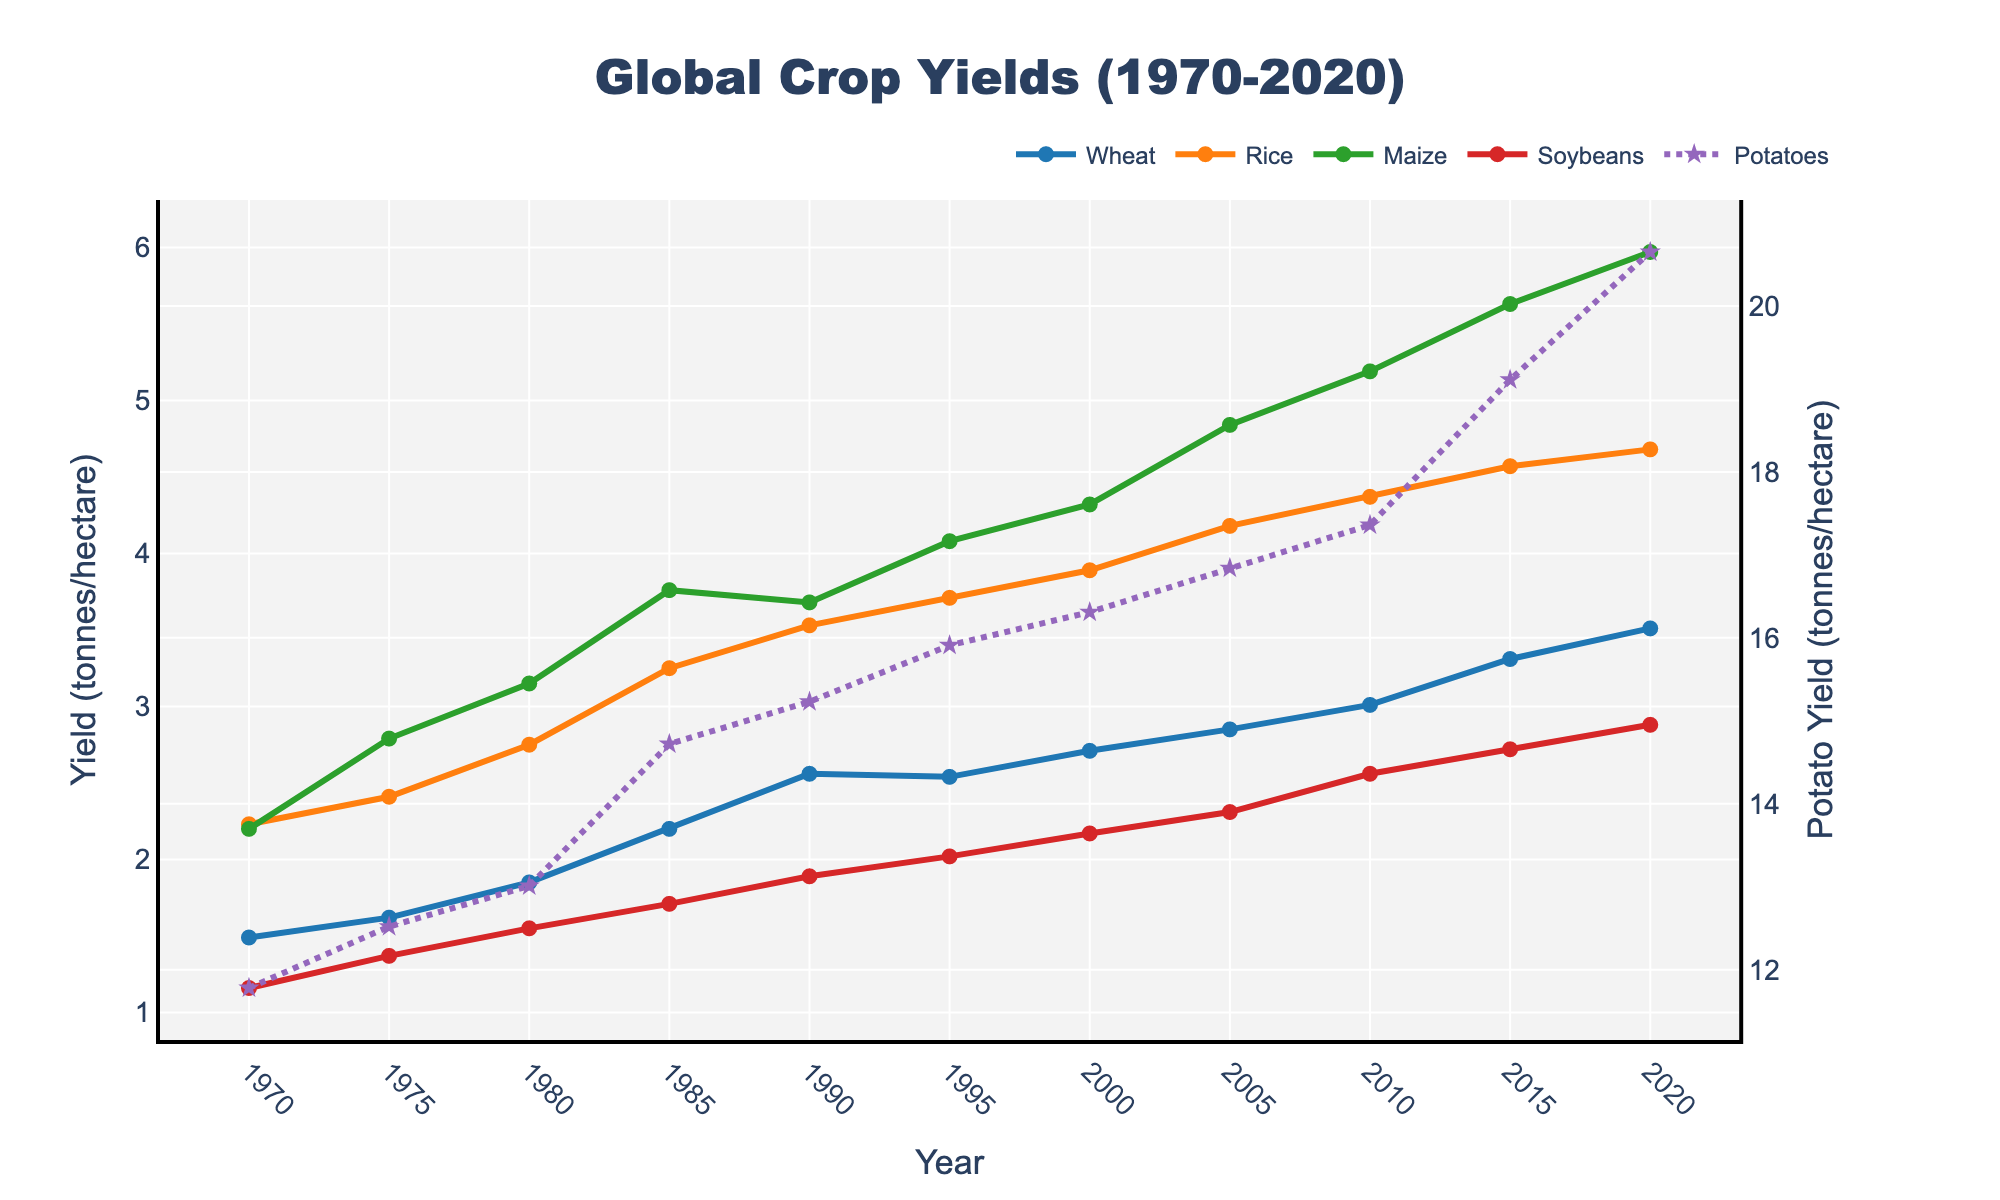What crop had the highest yield in 2020? Look at the endpoints of the lines in 2020 and compare their values. The highest among Wheat, Rice, Maize, Soybeans, and Potatoes is Potatoes with a yield of 20.65 tonnes/hectare.
Answer: Potatoes What is the difference in Soybeans yield between 2000 and 2020? Identify the yield values for Soybeans in 2000 and 2020 (2.17 and 2.88 tonnes/hectare respectively). Subtract the earlier value from the later value: 2.88 - 2.17 = 0.71.
Answer: 0.71 tonnes/hectare Which crop showed the most consistent increase in yield over the 50-year period? Observe the trend of each line from 1970 to 2020. The line for Rice shows a consistent increase without significant fluctuations.
Answer: Rice What is the average yield of Maize over the entire period? Sum the yield values for Maize over all the years and divide by the number of data points: (2.20 + 2.79 + 3.15 + 3.76 + 3.68 + 4.08 + 4.32 + 4.84 + 5.19 + 5.63 + 5.97) / 11 = 4.10.
Answer: 4.10 tonnes/hectare How does the yield growth of Potatoes compare to that of Wheat between 1970 and 2020? Calculate the difference for each: Potatoes (20.65 - 11.78) and Wheat (3.51 - 1.49). Compare the values: Potatoes (8.87), Wheat (2.02). Potatoes showed a larger increase.
Answer: Potatoes showed larger growth Which crop had the highest yield growth rate over the period? Determine the initial and final yield for each crop, compute the growth for all, and compare. Potatoes have the highest growth rate: (20.65 - 11.78) / 11 = 0.81 annual increase.
Answer: Potatoes Between 2005 and 2010, which crop had the largest increase in yield? Find the difference in yield for each crop between 2005 and 2010: Wheat (3.01 - 2.85), Rice (4.37 - 4.18), Maize (5.19 - 4.84), Soybeans (2.56 - 2.31), Potatoes (17.36 - 16.84). Maize shows the largest increase at 0.35 tonnes/hectare.
Answer: Maize What was the total yield of Rice over five selected years: 1970, 1980, 1990, 2000, 2010? Sum the Rice yield values for those years: 2.23 + 2.75 + 3.53 + 3.89 + 4.37 = 16.77.
Answer: 16.77 tonnes/hectare Which crops had a yield higher than 5 tonnes/hectare in 2015? Identify the yield values in 2015 and compare to 5: Wheat (3.31), Rice (4.57), Maize (5.63), Soybeans (2.72), Potatoes (19.11). Only Maize and Potatoes meet the criteria.
Answer: Maize and Potatoes What is the average yield increase per decade for Wheat from 1970 to 2020? Compute the yield increase for each decade: 1970-1980, 1.85 - 1.49; 1980-1990, 2.56 - 1.85; 1990-2000, 2.71 - 2.56; 2000-2010, 3.01 - 2.71; 2010-2020, 3.51 - 3.01. Then average them: (0.36 + 0.71 + 0.15 + 0.30 + 0.50) / 5 = 0.40.
Answer: 0.40 tonnes/hectare per decade 